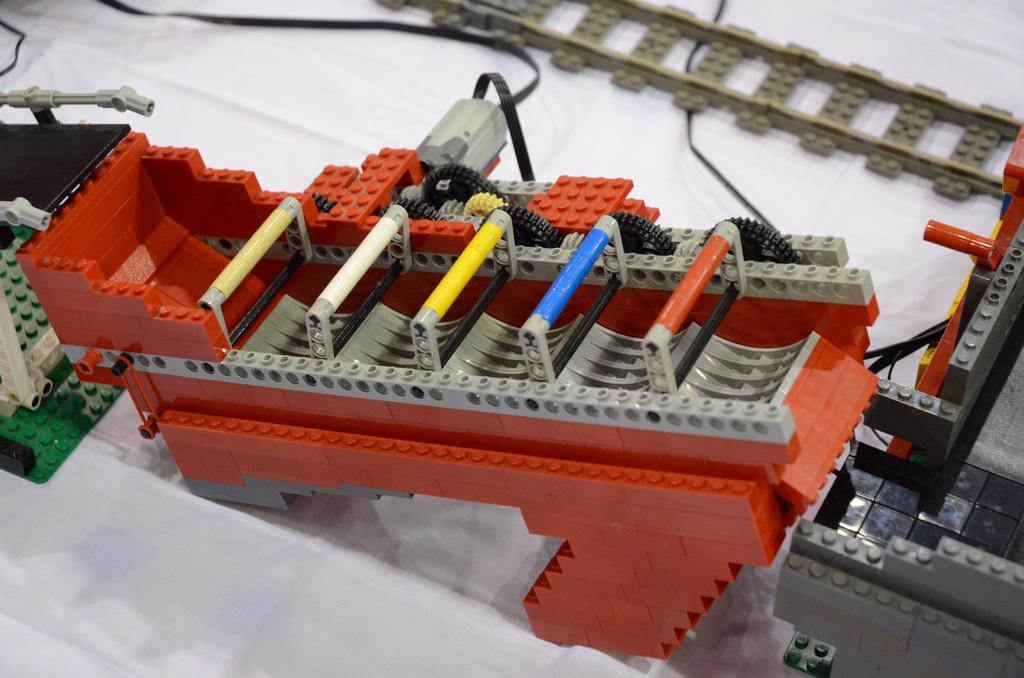What is the main subject of the image? The main subject of the image is a small toy train. How is the toy train positioned in the image? The toy train is on a track. What material is the track made of? The track is made with toy bricks. Can you see a crown on the toy train in the image? There is no crown present on the toy train in the image. What type of cheese is being used to build the track in the image? There is no cheese present in the image; the track is made with toy bricks. 